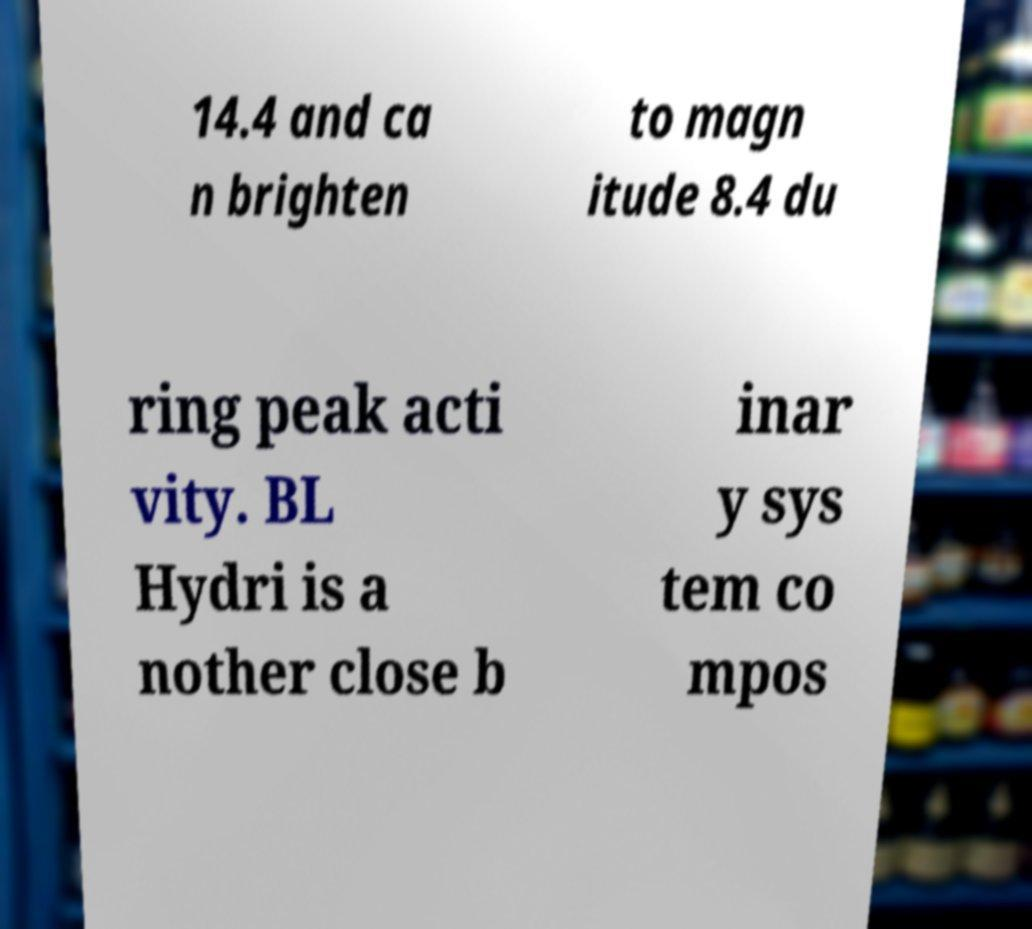What messages or text are displayed in this image? I need them in a readable, typed format. 14.4 and ca n brighten to magn itude 8.4 du ring peak acti vity. BL Hydri is a nother close b inar y sys tem co mpos 